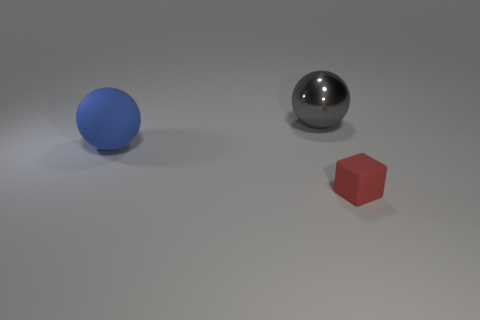Add 3 blue things. How many objects exist? 6 Subtract all red cubes. How many red balls are left? 0 Subtract all tiny red balls. Subtract all red cubes. How many objects are left? 2 Add 2 metallic things. How many metallic things are left? 3 Add 3 rubber blocks. How many rubber blocks exist? 4 Subtract 0 yellow cylinders. How many objects are left? 3 Subtract all cubes. How many objects are left? 2 Subtract all green cubes. Subtract all cyan spheres. How many cubes are left? 1 